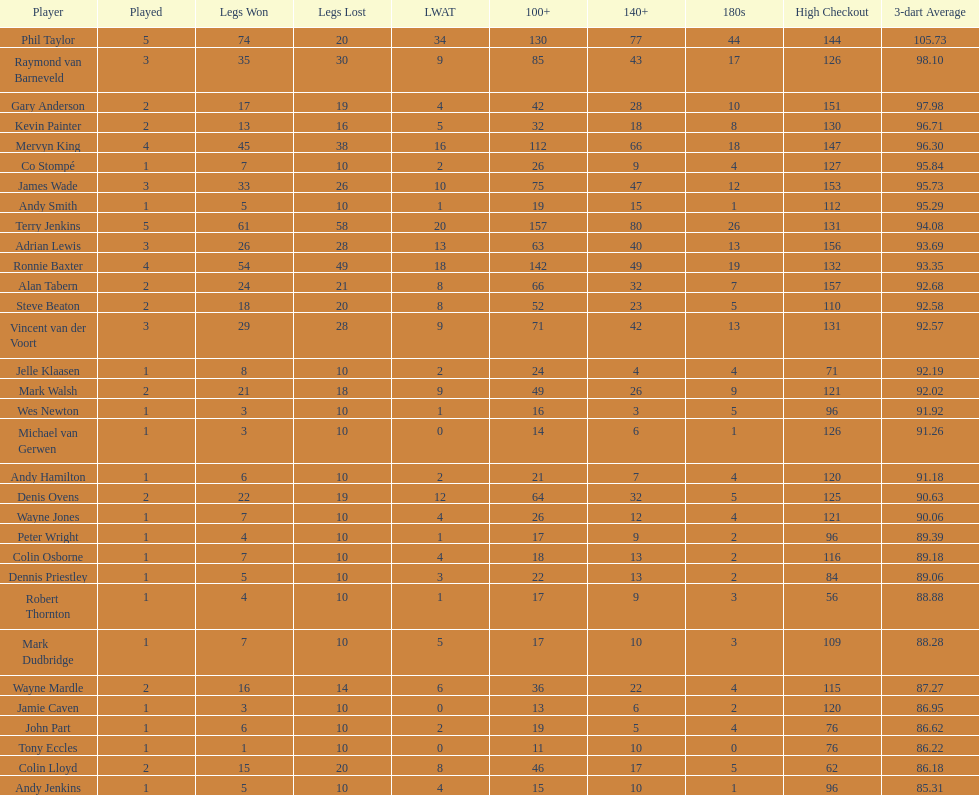Which player had the smallest loss? Co Stompé, Andy Smith, Jelle Klaasen, Wes Newton, Michael van Gerwen, Andy Hamilton, Wayne Jones, Peter Wright, Colin Osborne, Dennis Priestley, Robert Thornton, Mark Dudbridge, Jamie Caven, John Part, Tony Eccles, Andy Jenkins. Parse the full table. {'header': ['Player', 'Played', 'Legs Won', 'Legs Lost', 'LWAT', '100+', '140+', '180s', 'High Checkout', '3-dart Average'], 'rows': [['Phil Taylor', '5', '74', '20', '34', '130', '77', '44', '144', '105.73'], ['Raymond van Barneveld', '3', '35', '30', '9', '85', '43', '17', '126', '98.10'], ['Gary Anderson', '2', '17', '19', '4', '42', '28', '10', '151', '97.98'], ['Kevin Painter', '2', '13', '16', '5', '32', '18', '8', '130', '96.71'], ['Mervyn King', '4', '45', '38', '16', '112', '66', '18', '147', '96.30'], ['Co Stompé', '1', '7', '10', '2', '26', '9', '4', '127', '95.84'], ['James Wade', '3', '33', '26', '10', '75', '47', '12', '153', '95.73'], ['Andy Smith', '1', '5', '10', '1', '19', '15', '1', '112', '95.29'], ['Terry Jenkins', '5', '61', '58', '20', '157', '80', '26', '131', '94.08'], ['Adrian Lewis', '3', '26', '28', '13', '63', '40', '13', '156', '93.69'], ['Ronnie Baxter', '4', '54', '49', '18', '142', '49', '19', '132', '93.35'], ['Alan Tabern', '2', '24', '21', '8', '66', '32', '7', '157', '92.68'], ['Steve Beaton', '2', '18', '20', '8', '52', '23', '5', '110', '92.58'], ['Vincent van der Voort', '3', '29', '28', '9', '71', '42', '13', '131', '92.57'], ['Jelle Klaasen', '1', '8', '10', '2', '24', '4', '4', '71', '92.19'], ['Mark Walsh', '2', '21', '18', '9', '49', '26', '9', '121', '92.02'], ['Wes Newton', '1', '3', '10', '1', '16', '3', '5', '96', '91.92'], ['Michael van Gerwen', '1', '3', '10', '0', '14', '6', '1', '126', '91.26'], ['Andy Hamilton', '1', '6', '10', '2', '21', '7', '4', '120', '91.18'], ['Denis Ovens', '2', '22', '19', '12', '64', '32', '5', '125', '90.63'], ['Wayne Jones', '1', '7', '10', '4', '26', '12', '4', '121', '90.06'], ['Peter Wright', '1', '4', '10', '1', '17', '9', '2', '96', '89.39'], ['Colin Osborne', '1', '7', '10', '4', '18', '13', '2', '116', '89.18'], ['Dennis Priestley', '1', '5', '10', '3', '22', '13', '2', '84', '89.06'], ['Robert Thornton', '1', '4', '10', '1', '17', '9', '3', '56', '88.88'], ['Mark Dudbridge', '1', '7', '10', '5', '17', '10', '3', '109', '88.28'], ['Wayne Mardle', '2', '16', '14', '6', '36', '22', '4', '115', '87.27'], ['Jamie Caven', '1', '3', '10', '0', '13', '6', '2', '120', '86.95'], ['John Part', '1', '6', '10', '2', '19', '5', '4', '76', '86.62'], ['Tony Eccles', '1', '1', '10', '0', '11', '10', '0', '76', '86.22'], ['Colin Lloyd', '2', '15', '20', '8', '46', '17', '5', '62', '86.18'], ['Andy Jenkins', '1', '5', '10', '4', '15', '10', '1', '96', '85.31']]} 